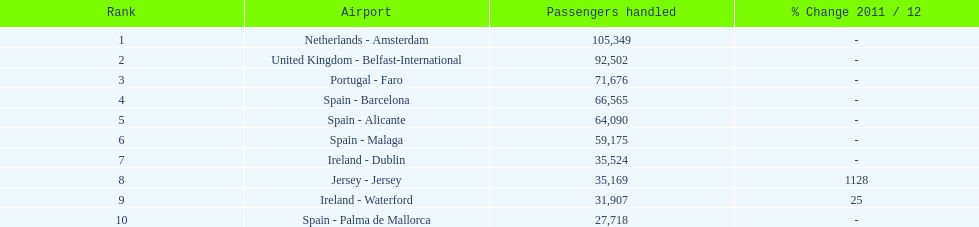What is the name of the sole airport in portugal that ranks among the top 10 busiest routes to and from london southend airport in 2012? Portugal - Faro. 